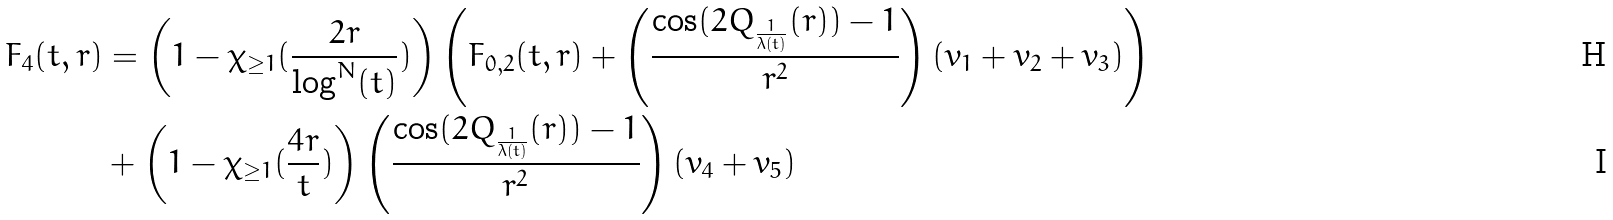<formula> <loc_0><loc_0><loc_500><loc_500>F _ { 4 } ( t , r ) & = \left ( 1 - \chi _ { \geq 1 } ( \frac { 2 r } { \log ^ { N } ( t ) } ) \right ) \left ( F _ { 0 , 2 } ( t , r ) + \left ( \frac { \cos ( 2 Q _ { \frac { 1 } { \lambda ( t ) } } ( r ) ) - 1 } { r ^ { 2 } } \right ) \left ( v _ { 1 } + v _ { 2 } + v _ { 3 } \right ) \right ) \\ & + \left ( 1 - \chi _ { \geq 1 } ( \frac { 4 r } { t } ) \right ) \left ( \frac { \cos ( 2 Q _ { \frac { 1 } { \lambda ( t ) } } ( r ) ) - 1 } { r ^ { 2 } } \right ) \left ( v _ { 4 } + v _ { 5 } \right )</formula> 